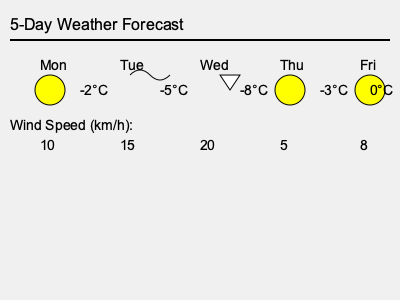Based on the 5-day weather forecast shown, which day would be most suitable for the young snowboarder to practice on the slopes, considering both temperature and wind conditions? To determine the most suitable day for snowboarding practice, we need to consider both temperature and wind conditions:

1. Temperature:
   - Ideal temperatures for snowboarding are typically between -7°C and -1°C.
   - Mon: -2°C, Tue: -5°C, Wed: -8°C, Thu: -3°C, Fri: 0°C
   
2. Wind speed:
   - Lower wind speeds are generally better for snowboarding.
   - Mon: 10 km/h, Tue: 15 km/h, Wed: 20 km/h, Thu: 5 km/h, Fri: 8 km/h

3. Weather symbols:
   - Sun symbol indicates clear skies, which is favorable.
   - Cloud symbol suggests overcast conditions, still acceptable.
   - Snowflake symbol indicates snowfall, which can be good for fresh powder but may reduce visibility.

Analyzing each day:
- Monday: Good temperature, moderate wind, sunny.
- Tuesday: Good temperature, higher wind, cloudy.
- Wednesday: Slightly too cold, highest wind, snowing (potential visibility issues).
- Thursday: Good temperature, lowest wind, sunny (best combination).
- Friday: Temperature slightly too warm (may affect snow quality), low wind, sunny.

Considering all factors, Thursday offers the best combination of temperature (-3°C), wind conditions (5 km/h), and clear weather for snowboarding practice.
Answer: Thursday 